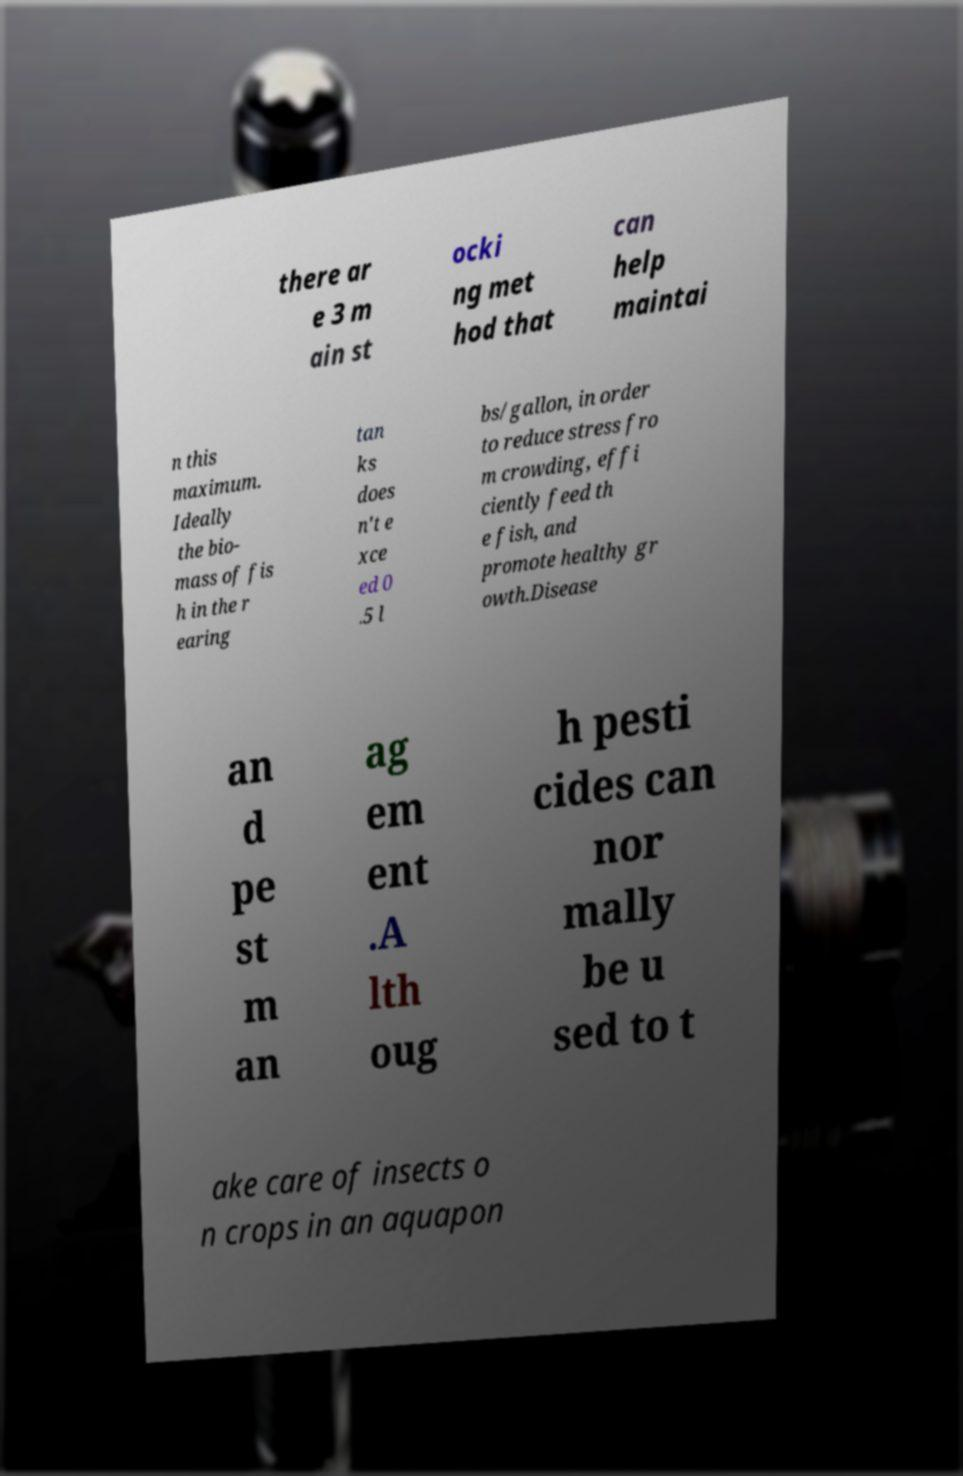For documentation purposes, I need the text within this image transcribed. Could you provide that? there ar e 3 m ain st ocki ng met hod that can help maintai n this maximum. Ideally the bio- mass of fis h in the r earing tan ks does n't e xce ed 0 .5 l bs/gallon, in order to reduce stress fro m crowding, effi ciently feed th e fish, and promote healthy gr owth.Disease an d pe st m an ag em ent .A lth oug h pesti cides can nor mally be u sed to t ake care of insects o n crops in an aquapon 